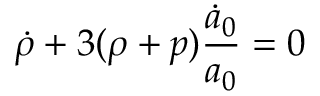Convert formula to latex. <formula><loc_0><loc_0><loc_500><loc_500>\dot { \rho } + 3 ( \rho + p ) \frac { \dot { a } _ { 0 } } { a _ { 0 } } = 0</formula> 